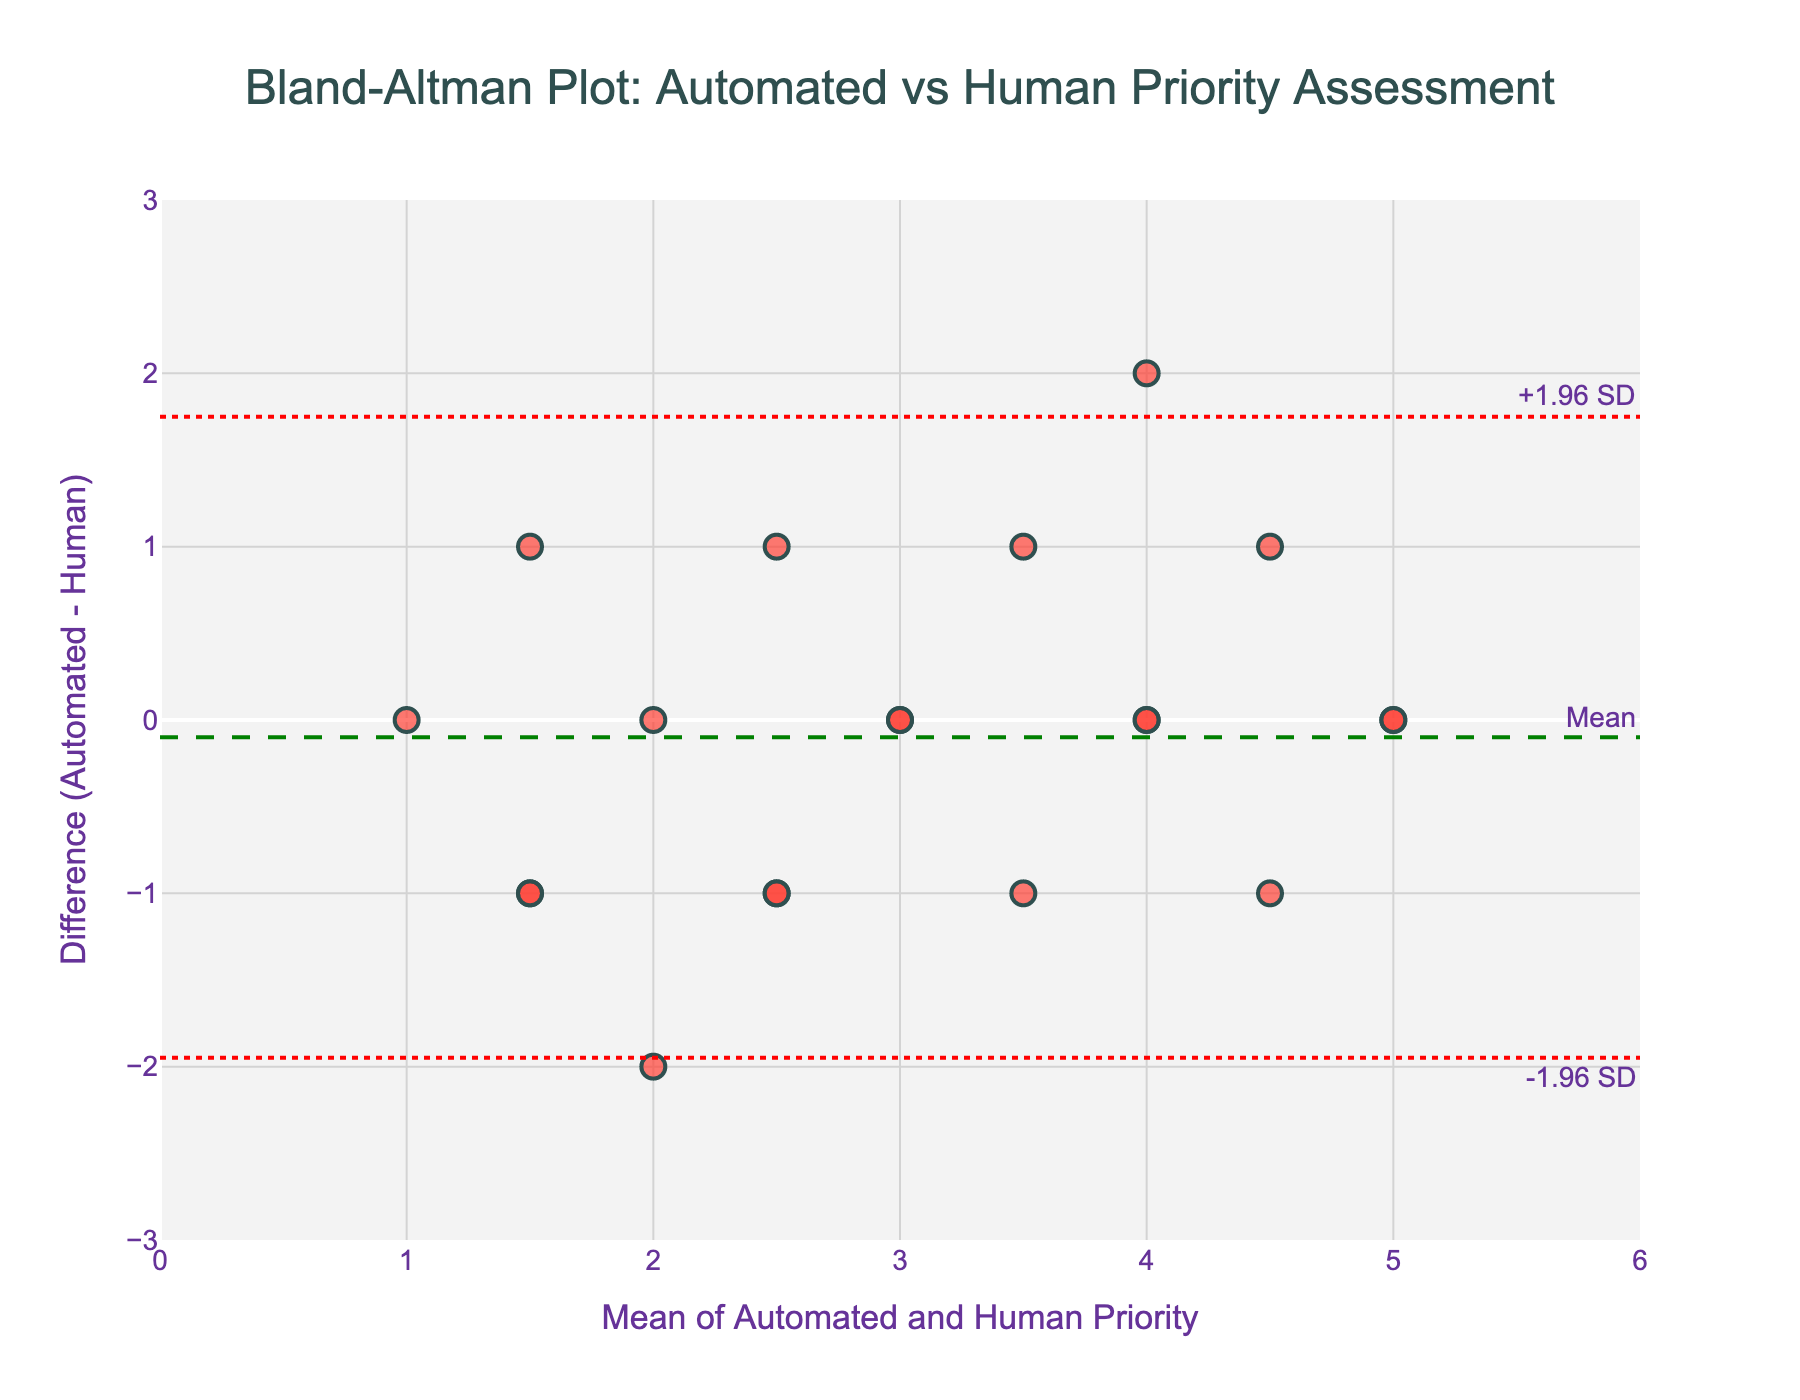What's the title of the plot? The title of the plot is displayed prominently at the top, indicating what the plot is about. It helps understand the context of the data being shown.
Answer: "Bland-Altman Plot: Automated vs Human Priority Assessment" What is the range of the x-axis? The x-axis range can be seen from the axis labels and ticks at the bottom of the plot. It shows the span of the mean values of automated and human priority assessments.
Answer: 0 to 6 How many data points in the plot have a difference of zero? To determine the number of data points with a difference of zero, we look for the scatter points that align horizontally with the y-axis value of zero. These points represent instances where automated and human priorities are equal.
Answer: 9 What is the mean difference between automated and human priorities? The mean difference is represented by the dashed horizontal line labeled "Mean" on the plot. This line indicates the average of the differences between automated and human assessments.
Answer: 0 What are the limits of agreement for the differences? The limits of agreement are shown as dotted horizontal lines labeled "+1.96 SD" and "-1.96 SD" on the plot. These lines indicate the range within which most differences between automated and human priorities fall.
Answer: +1.96 SD: ~1.5, -1.96 SD: ~-1.5 What is the highest positive difference observed in the data? The highest positive difference can be seen by identifying the highest point on the scatter plot above the mean line. This represents the maximum positive deviation between automated and human priorities.
Answer: 2 Are there any data points outside the limits of agreement? To determine if any data points lie outside the limits of agreement, we examine the scatter plot for any points above the upper dotted line or below the lower dotted line. These points would indicate outliers in the data.
Answer: No How does the variability in differences change as the mean priority increases? By observing the spread of data points across different mean priority values, we can infer whether the variability in differences grows or shrinks. A larger spread indicates higher variability with increasing mean priority.
Answer: Does not visibly change What does it mean if a data point lies on the mean line of the plot? If a data point is on the mean line, it signifies that the difference between automated and human priorities for that data point is equal to the mean difference. This gives an idea of its relative accuracy compared to the average difference.
Answer: Difference equals mean What does a cluster of points around the mean difference indicate about the two methods of assessment? A cluster of points around the mean difference line suggests strong agreement between automated and human assessments. The differences are consistently close to the average difference, implying similar performance from both methods.
Answer: Strong agreement 